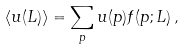<formula> <loc_0><loc_0><loc_500><loc_500>\langle u ( L ) \rangle = \sum _ { p } u ( p ) f ( p ; L ) \, ,</formula> 